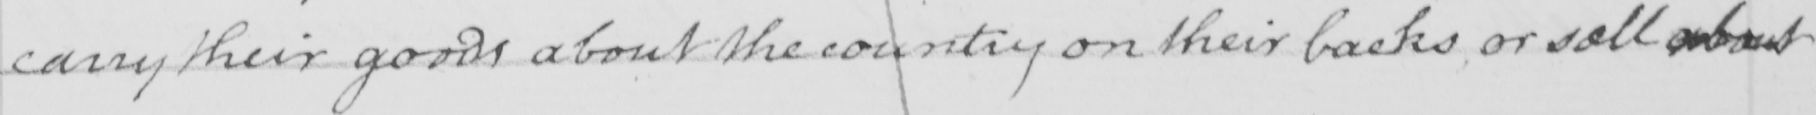Can you read and transcribe this handwriting? carry their goods about the country on their backs or sell about 